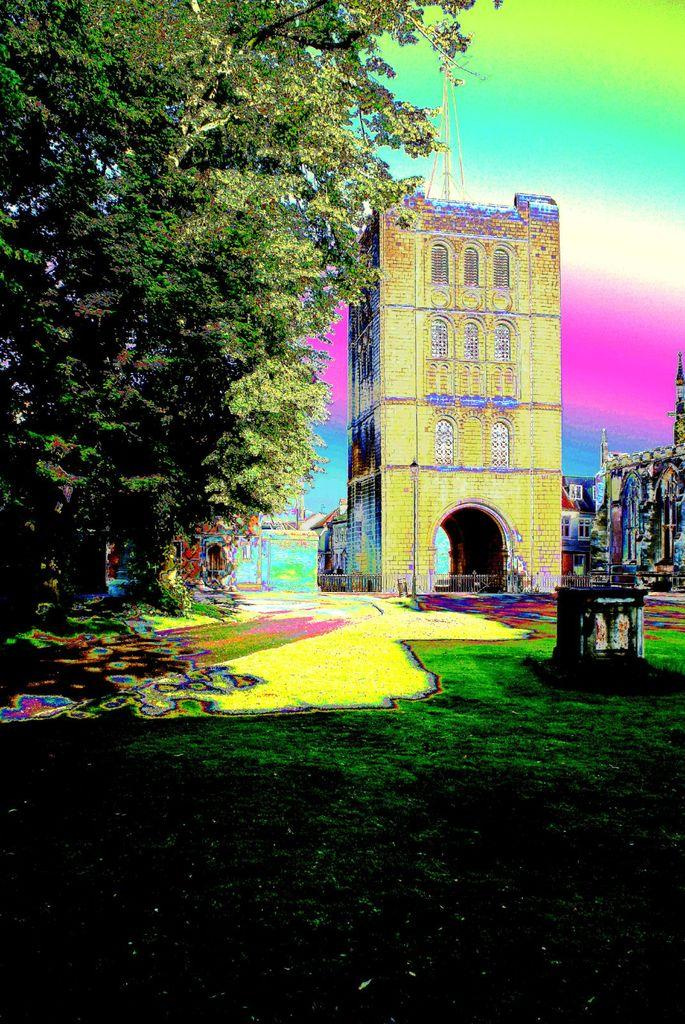What type of vegetation can be seen in the image? There is grass in the image. What type of structure is present in the image? There is a fence in the image. What other natural elements can be seen in the image? There are trees in the image. What type of man-made structures are visible in the image? There are buildings and a tower in the image. How would you describe the overall appearance of the image? The background of the image is colorful. What type of feast is being prepared in the image? There is no indication of a feast or any food preparation in the image. Can you describe the trip that the tower is taking in the image? The tower is stationary in the image and not taking any trip. 